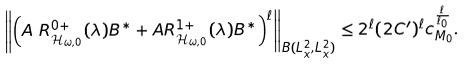Convert formula to latex. <formula><loc_0><loc_0><loc_500><loc_500>& \left \| \left ( A \ R _ { \mathcal { H } _ { \omega , 0 } } ^ { 0 + } ( \lambda ) B ^ { * } + A R _ { \mathcal { H } _ { \omega , 0 } } ^ { 1 + } ( \lambda ) B ^ { * } \right ) ^ { \ell } \right \| _ { B ( L ^ { 2 } _ { x } , L ^ { 2 } _ { x } ) } \leq 2 ^ { \ell } ( 2 C ^ { \prime } ) ^ { \ell } c _ { M _ { 0 } } ^ { \frac { \ell } { \ell _ { 0 } } } .</formula> 